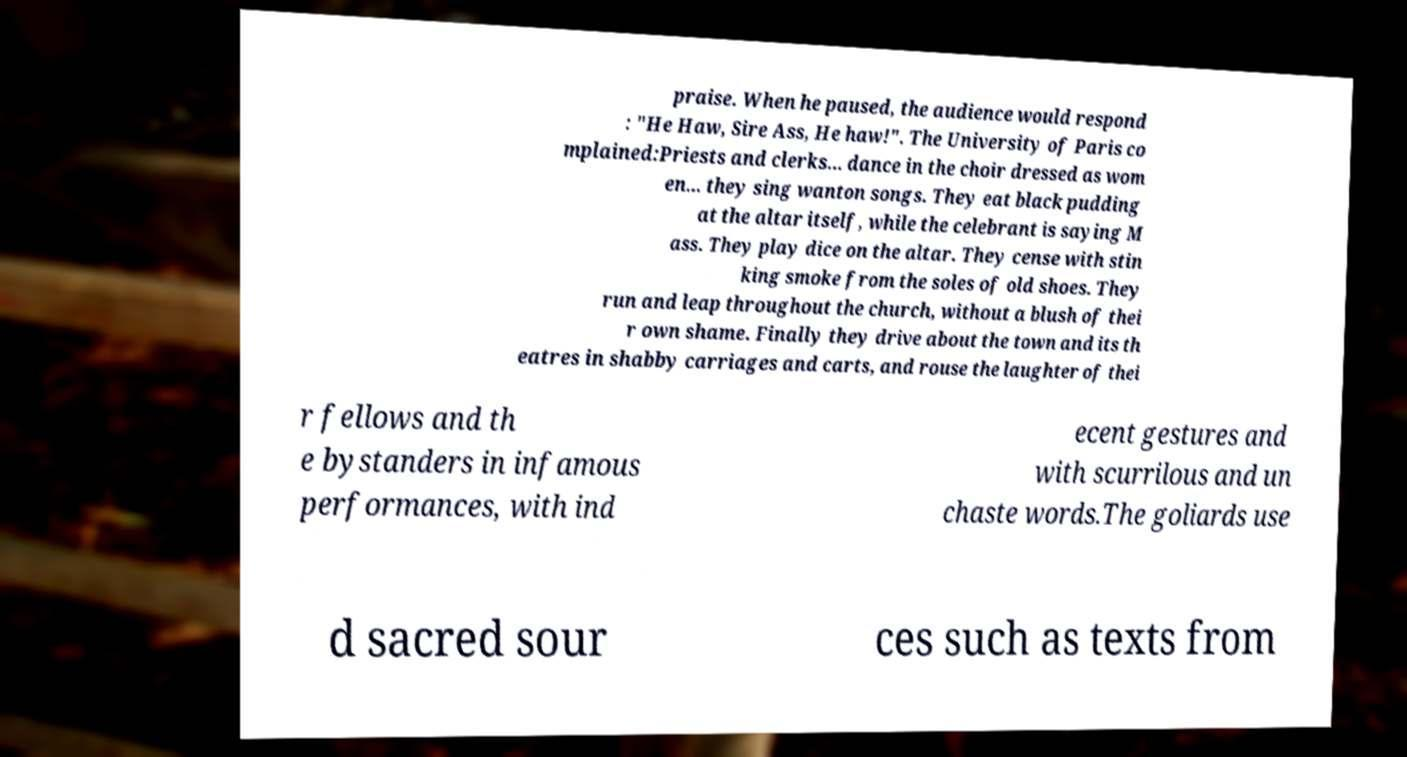Could you extract and type out the text from this image? praise. When he paused, the audience would respond : "He Haw, Sire Ass, He haw!". The University of Paris co mplained:Priests and clerks... dance in the choir dressed as wom en... they sing wanton songs. They eat black pudding at the altar itself, while the celebrant is saying M ass. They play dice on the altar. They cense with stin king smoke from the soles of old shoes. They run and leap throughout the church, without a blush of thei r own shame. Finally they drive about the town and its th eatres in shabby carriages and carts, and rouse the laughter of thei r fellows and th e bystanders in infamous performances, with ind ecent gestures and with scurrilous and un chaste words.The goliards use d sacred sour ces such as texts from 